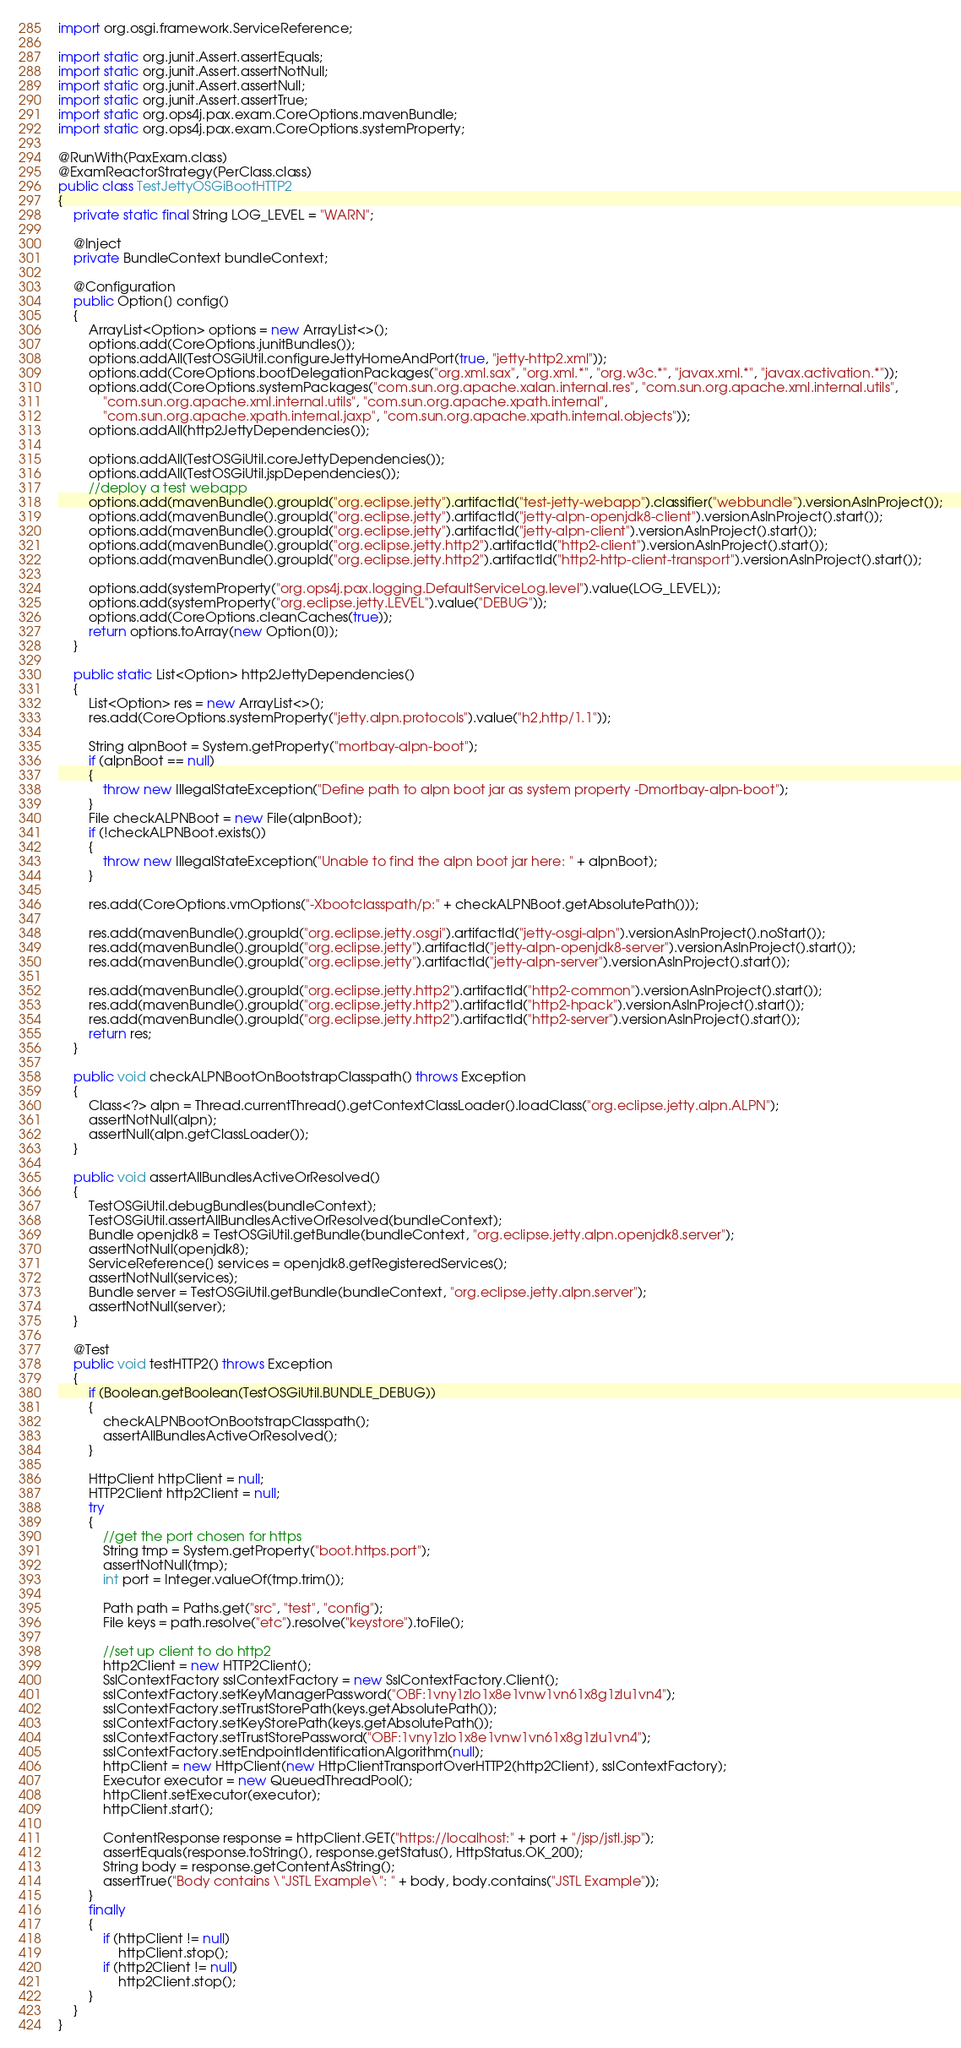<code> <loc_0><loc_0><loc_500><loc_500><_Java_>import org.osgi.framework.ServiceReference;

import static org.junit.Assert.assertEquals;
import static org.junit.Assert.assertNotNull;
import static org.junit.Assert.assertNull;
import static org.junit.Assert.assertTrue;
import static org.ops4j.pax.exam.CoreOptions.mavenBundle;
import static org.ops4j.pax.exam.CoreOptions.systemProperty;

@RunWith(PaxExam.class)
@ExamReactorStrategy(PerClass.class)
public class TestJettyOSGiBootHTTP2
{
    private static final String LOG_LEVEL = "WARN";

    @Inject
    private BundleContext bundleContext;

    @Configuration
    public Option[] config()
    {
        ArrayList<Option> options = new ArrayList<>();
        options.add(CoreOptions.junitBundles());
        options.addAll(TestOSGiUtil.configureJettyHomeAndPort(true, "jetty-http2.xml"));
        options.add(CoreOptions.bootDelegationPackages("org.xml.sax", "org.xml.*", "org.w3c.*", "javax.xml.*", "javax.activation.*"));
        options.add(CoreOptions.systemPackages("com.sun.org.apache.xalan.internal.res", "com.sun.org.apache.xml.internal.utils",
            "com.sun.org.apache.xml.internal.utils", "com.sun.org.apache.xpath.internal",
            "com.sun.org.apache.xpath.internal.jaxp", "com.sun.org.apache.xpath.internal.objects"));
        options.addAll(http2JettyDependencies());

        options.addAll(TestOSGiUtil.coreJettyDependencies());
        options.addAll(TestOSGiUtil.jspDependencies());
        //deploy a test webapp
        options.add(mavenBundle().groupId("org.eclipse.jetty").artifactId("test-jetty-webapp").classifier("webbundle").versionAsInProject());
        options.add(mavenBundle().groupId("org.eclipse.jetty").artifactId("jetty-alpn-openjdk8-client").versionAsInProject().start());
        options.add(mavenBundle().groupId("org.eclipse.jetty").artifactId("jetty-alpn-client").versionAsInProject().start());
        options.add(mavenBundle().groupId("org.eclipse.jetty.http2").artifactId("http2-client").versionAsInProject().start());
        options.add(mavenBundle().groupId("org.eclipse.jetty.http2").artifactId("http2-http-client-transport").versionAsInProject().start());

        options.add(systemProperty("org.ops4j.pax.logging.DefaultServiceLog.level").value(LOG_LEVEL));
        options.add(systemProperty("org.eclipse.jetty.LEVEL").value("DEBUG"));
        options.add(CoreOptions.cleanCaches(true));
        return options.toArray(new Option[0]);
    }

    public static List<Option> http2JettyDependencies()
    {
        List<Option> res = new ArrayList<>();
        res.add(CoreOptions.systemProperty("jetty.alpn.protocols").value("h2,http/1.1"));

        String alpnBoot = System.getProperty("mortbay-alpn-boot");
        if (alpnBoot == null)
        {
            throw new IllegalStateException("Define path to alpn boot jar as system property -Dmortbay-alpn-boot");
        }
        File checkALPNBoot = new File(alpnBoot);
        if (!checkALPNBoot.exists())
        {
            throw new IllegalStateException("Unable to find the alpn boot jar here: " + alpnBoot);
        }

        res.add(CoreOptions.vmOptions("-Xbootclasspath/p:" + checkALPNBoot.getAbsolutePath()));

        res.add(mavenBundle().groupId("org.eclipse.jetty.osgi").artifactId("jetty-osgi-alpn").versionAsInProject().noStart());
        res.add(mavenBundle().groupId("org.eclipse.jetty").artifactId("jetty-alpn-openjdk8-server").versionAsInProject().start());
        res.add(mavenBundle().groupId("org.eclipse.jetty").artifactId("jetty-alpn-server").versionAsInProject().start());

        res.add(mavenBundle().groupId("org.eclipse.jetty.http2").artifactId("http2-common").versionAsInProject().start());
        res.add(mavenBundle().groupId("org.eclipse.jetty.http2").artifactId("http2-hpack").versionAsInProject().start());
        res.add(mavenBundle().groupId("org.eclipse.jetty.http2").artifactId("http2-server").versionAsInProject().start());
        return res;
    }

    public void checkALPNBootOnBootstrapClasspath() throws Exception
    {
        Class<?> alpn = Thread.currentThread().getContextClassLoader().loadClass("org.eclipse.jetty.alpn.ALPN");
        assertNotNull(alpn);
        assertNull(alpn.getClassLoader());
    }

    public void assertAllBundlesActiveOrResolved()
    {
        TestOSGiUtil.debugBundles(bundleContext);
        TestOSGiUtil.assertAllBundlesActiveOrResolved(bundleContext);
        Bundle openjdk8 = TestOSGiUtil.getBundle(bundleContext, "org.eclipse.jetty.alpn.openjdk8.server");
        assertNotNull(openjdk8);
        ServiceReference[] services = openjdk8.getRegisteredServices();
        assertNotNull(services);
        Bundle server = TestOSGiUtil.getBundle(bundleContext, "org.eclipse.jetty.alpn.server");
        assertNotNull(server);
    }

    @Test
    public void testHTTP2() throws Exception
    {
        if (Boolean.getBoolean(TestOSGiUtil.BUNDLE_DEBUG))
        {
            checkALPNBootOnBootstrapClasspath();
            assertAllBundlesActiveOrResolved();
        }

        HttpClient httpClient = null;
        HTTP2Client http2Client = null;
        try
        {
            //get the port chosen for https
            String tmp = System.getProperty("boot.https.port");
            assertNotNull(tmp);
            int port = Integer.valueOf(tmp.trim());

            Path path = Paths.get("src", "test", "config");
            File keys = path.resolve("etc").resolve("keystore").toFile();

            //set up client to do http2
            http2Client = new HTTP2Client();
            SslContextFactory sslContextFactory = new SslContextFactory.Client();
            sslContextFactory.setKeyManagerPassword("OBF:1vny1zlo1x8e1vnw1vn61x8g1zlu1vn4");
            sslContextFactory.setTrustStorePath(keys.getAbsolutePath());
            sslContextFactory.setKeyStorePath(keys.getAbsolutePath());
            sslContextFactory.setTrustStorePassword("OBF:1vny1zlo1x8e1vnw1vn61x8g1zlu1vn4");
            sslContextFactory.setEndpointIdentificationAlgorithm(null);
            httpClient = new HttpClient(new HttpClientTransportOverHTTP2(http2Client), sslContextFactory);
            Executor executor = new QueuedThreadPool();
            httpClient.setExecutor(executor);
            httpClient.start();

            ContentResponse response = httpClient.GET("https://localhost:" + port + "/jsp/jstl.jsp");
            assertEquals(response.toString(), response.getStatus(), HttpStatus.OK_200);
            String body = response.getContentAsString();
            assertTrue("Body contains \"JSTL Example\": " + body, body.contains("JSTL Example"));
        }
        finally
        {
            if (httpClient != null)
                httpClient.stop();
            if (http2Client != null)
                http2Client.stop();
        }
    }
}
</code> 